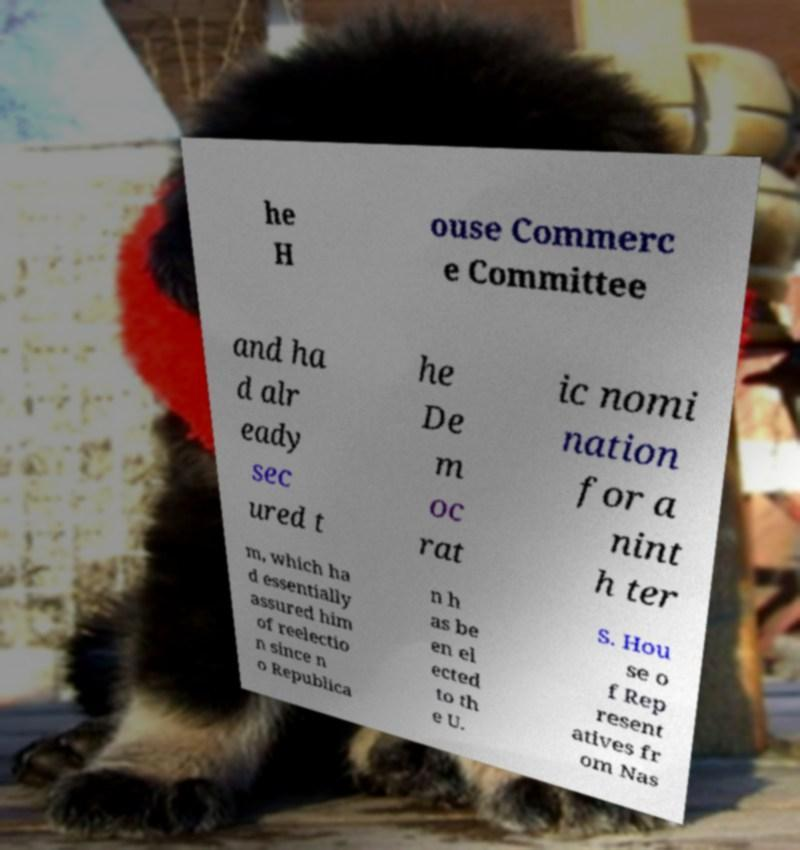Please identify and transcribe the text found in this image. he H ouse Commerc e Committee and ha d alr eady sec ured t he De m oc rat ic nomi nation for a nint h ter m, which ha d essentially assured him of reelectio n since n o Republica n h as be en el ected to th e U. S. Hou se o f Rep resent atives fr om Nas 